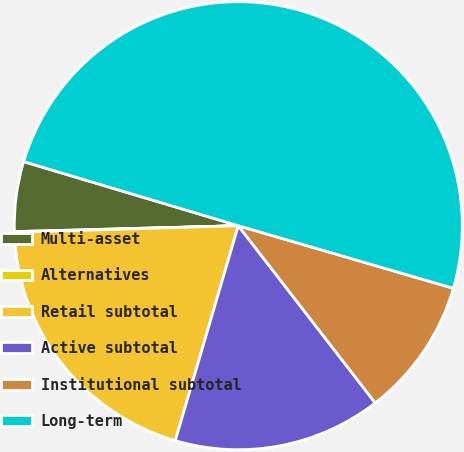Convert chart. <chart><loc_0><loc_0><loc_500><loc_500><pie_chart><fcel>Multi-asset<fcel>Alternatives<fcel>Retail subtotal<fcel>Active subtotal<fcel>Institutional subtotal<fcel>Long-term<nl><fcel>5.04%<fcel>0.05%<fcel>19.99%<fcel>15.01%<fcel>10.02%<fcel>49.89%<nl></chart> 